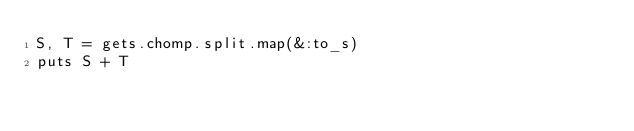<code> <loc_0><loc_0><loc_500><loc_500><_Ruby_>S, T = gets.chomp.split.map(&:to_s)
puts S + T</code> 